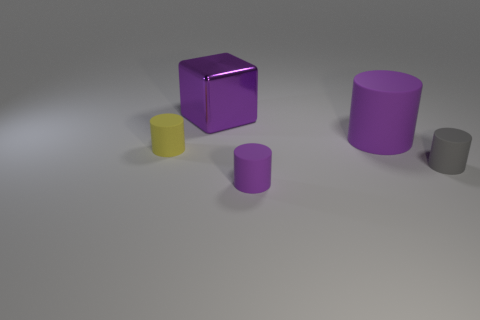Subtract all gray cylinders. How many cylinders are left? 3 Subtract all small yellow matte cylinders. How many cylinders are left? 3 Add 1 small yellow matte things. How many objects exist? 6 Subtract all gray cylinders. Subtract all red spheres. How many cylinders are left? 3 Subtract all cylinders. How many objects are left? 1 Add 3 big blocks. How many big blocks are left? 4 Add 4 tiny things. How many tiny things exist? 7 Subtract 1 gray cylinders. How many objects are left? 4 Subtract all gray objects. Subtract all small gray matte cylinders. How many objects are left? 3 